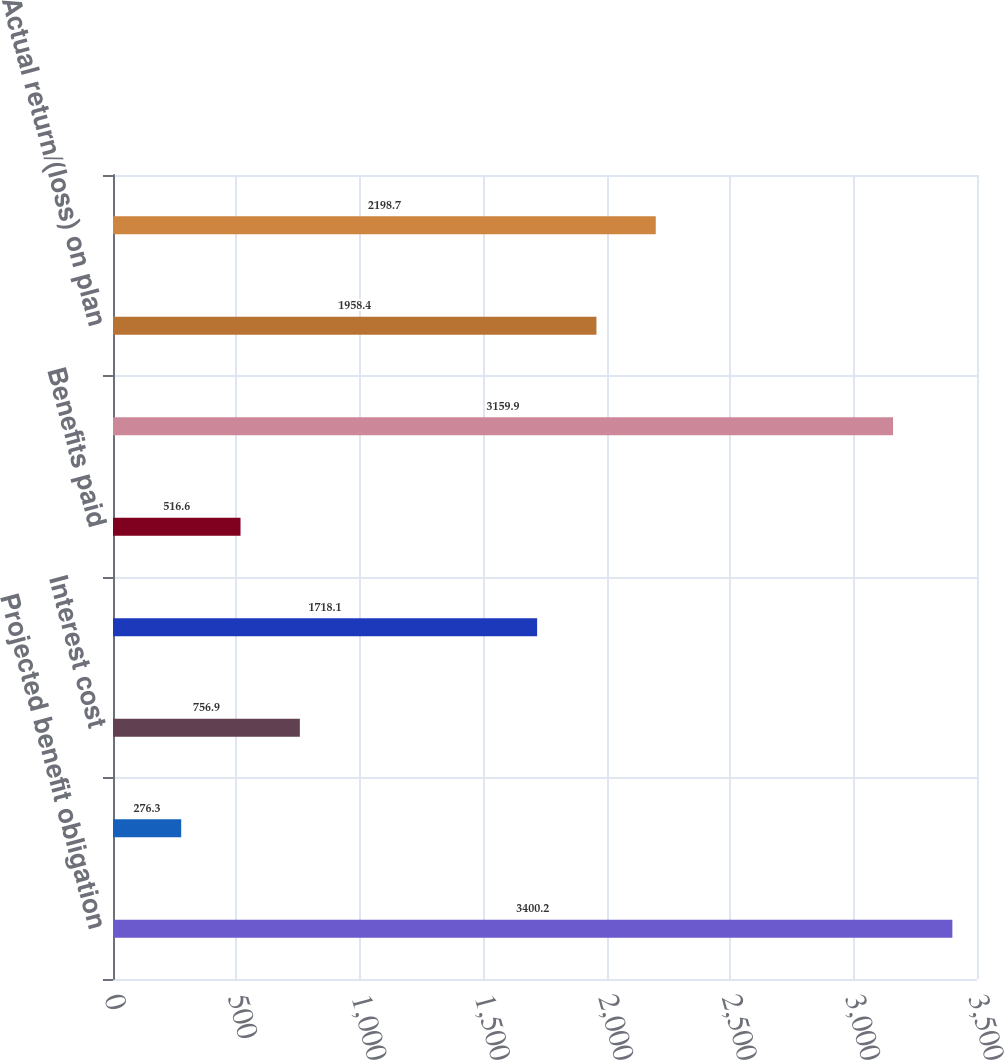Convert chart. <chart><loc_0><loc_0><loc_500><loc_500><bar_chart><fcel>Projected benefit obligation<fcel>Service cost<fcel>Interest cost<fcel>Actuarial losses/(gains)<fcel>Benefits paid<fcel>Plan assets at fair value at<fcel>Actual return/(loss) on plan<fcel>Company contributions<nl><fcel>3400.2<fcel>276.3<fcel>756.9<fcel>1718.1<fcel>516.6<fcel>3159.9<fcel>1958.4<fcel>2198.7<nl></chart> 